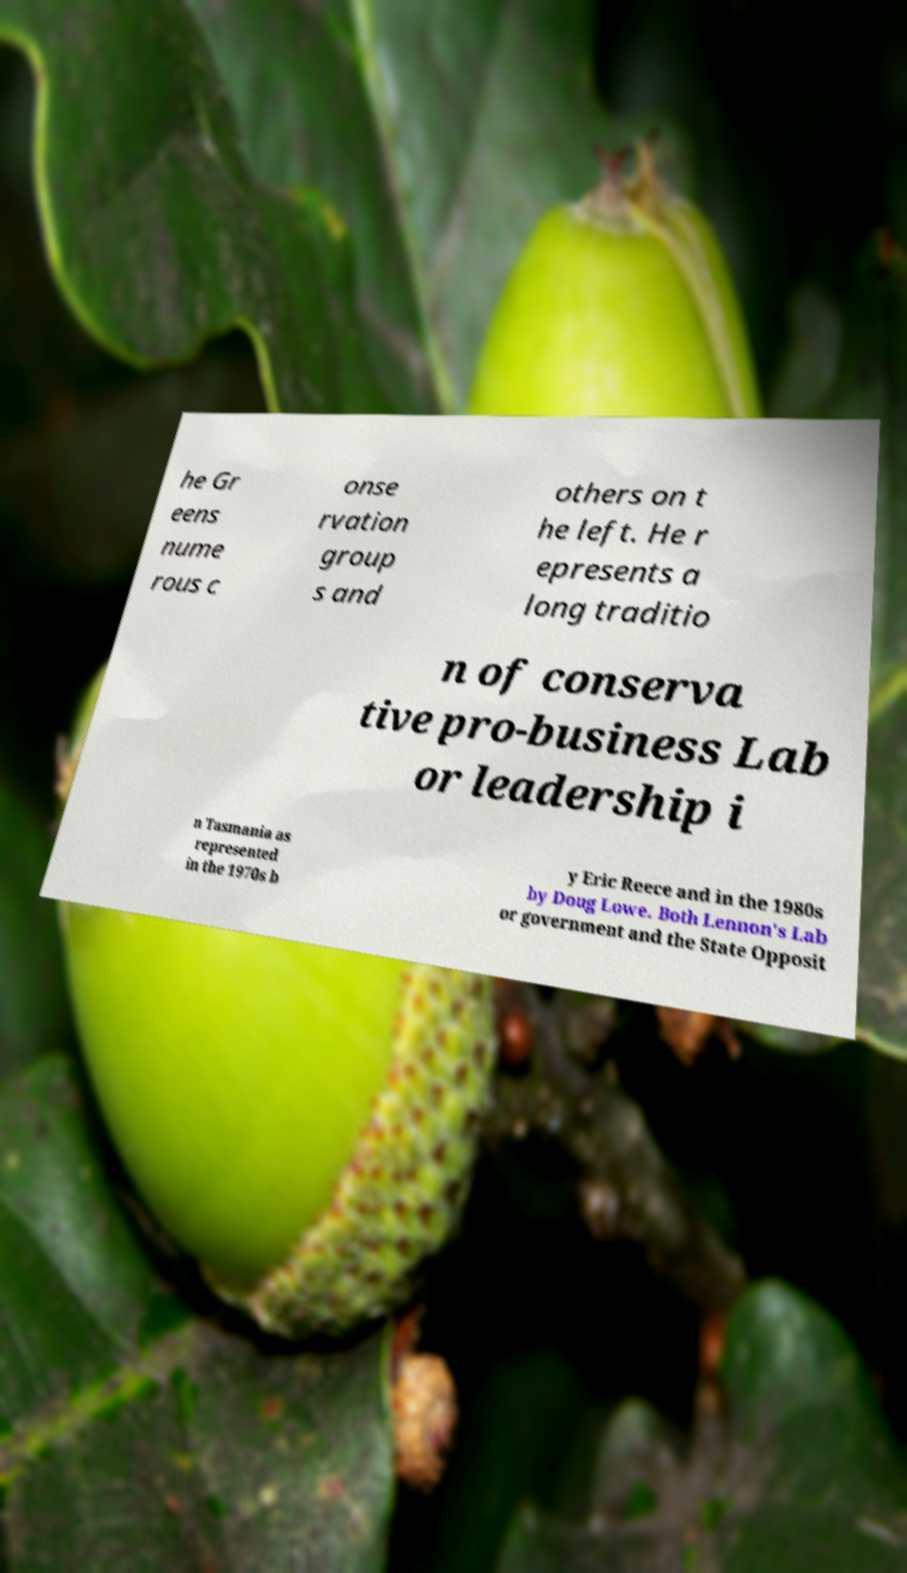Please read and relay the text visible in this image. What does it say? he Gr eens nume rous c onse rvation group s and others on t he left. He r epresents a long traditio n of conserva tive pro-business Lab or leadership i n Tasmania as represented in the 1970s b y Eric Reece and in the 1980s by Doug Lowe. Both Lennon's Lab or government and the State Opposit 